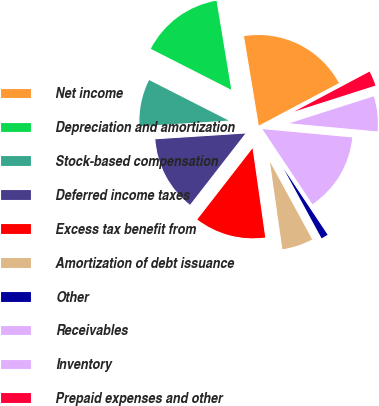Convert chart. <chart><loc_0><loc_0><loc_500><loc_500><pie_chart><fcel>Net income<fcel>Depreciation and amortization<fcel>Stock-based compensation<fcel>Deferred income taxes<fcel>Excess tax benefit from<fcel>Amortization of debt issuance<fcel>Other<fcel>Receivables<fcel>Inventory<fcel>Prepaid expenses and other<nl><fcel>19.85%<fcel>14.89%<fcel>8.51%<fcel>13.47%<fcel>12.76%<fcel>5.68%<fcel>1.42%<fcel>14.18%<fcel>6.39%<fcel>2.84%<nl></chart> 